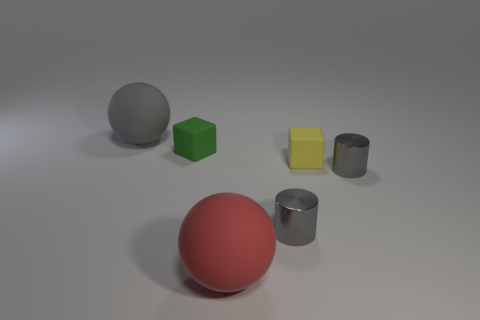Add 3 gray shiny objects. How many objects exist? 9 Subtract all gray metal cylinders. Subtract all cylinders. How many objects are left? 2 Add 6 tiny cubes. How many tiny cubes are left? 8 Add 3 big cyan metallic spheres. How many big cyan metallic spheres exist? 3 Subtract 0 yellow spheres. How many objects are left? 6 Subtract all balls. How many objects are left? 4 Subtract 1 cubes. How many cubes are left? 1 Subtract all cyan balls. Subtract all yellow cylinders. How many balls are left? 2 